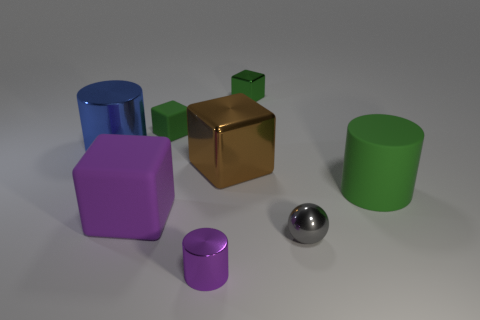Subtract all metal cylinders. How many cylinders are left? 1 Add 1 cylinders. How many objects exist? 9 Subtract all brown blocks. How many blocks are left? 3 Subtract all red cylinders. How many purple blocks are left? 1 Subtract all balls. How many objects are left? 7 Subtract 2 cylinders. How many cylinders are left? 1 Subtract all brown cylinders. Subtract all yellow spheres. How many cylinders are left? 3 Subtract all purple shiny balls. Subtract all purple cubes. How many objects are left? 7 Add 7 rubber cylinders. How many rubber cylinders are left? 8 Add 7 green blocks. How many green blocks exist? 9 